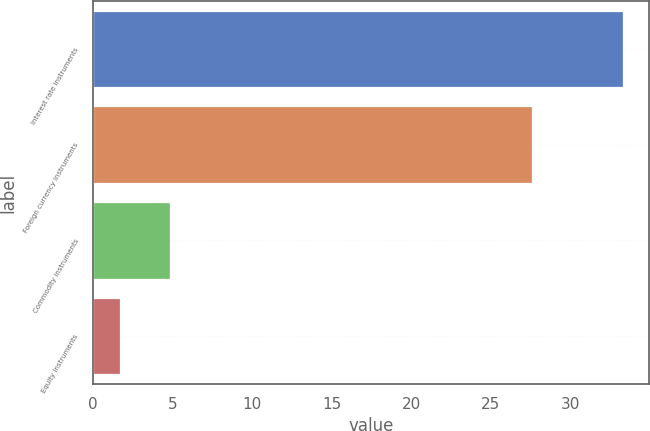Convert chart to OTSL. <chart><loc_0><loc_0><loc_500><loc_500><bar_chart><fcel>Interest rate instruments<fcel>Foreign currency instruments<fcel>Commodity instruments<fcel>Equity instruments<nl><fcel>33.3<fcel>27.6<fcel>4.86<fcel>1.7<nl></chart> 